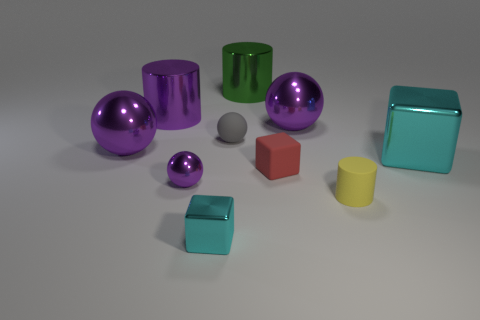There is a big cube that is the same color as the small metallic block; what material is it?
Ensure brevity in your answer.  Metal. Is there another big thing of the same shape as the green metallic thing?
Keep it short and to the point. Yes. There is a thing that is behind the big purple metallic cylinder; does it have the same shape as the yellow object in front of the red rubber object?
Provide a short and direct response. Yes. Are there any gray spheres that have the same size as the matte block?
Make the answer very short. Yes. Are there the same number of purple objects that are to the right of the tiny yellow cylinder and matte objects that are left of the green object?
Your answer should be compact. No. Does the large cylinder that is behind the purple shiny cylinder have the same material as the big cylinder to the left of the small purple ball?
Ensure brevity in your answer.  Yes. What is the tiny cyan cube made of?
Your answer should be compact. Metal. What number of other objects are the same color as the big block?
Your response must be concise. 1. Is the tiny metallic cube the same color as the large metal block?
Your response must be concise. Yes. How many large brown metallic cylinders are there?
Your response must be concise. 0. 